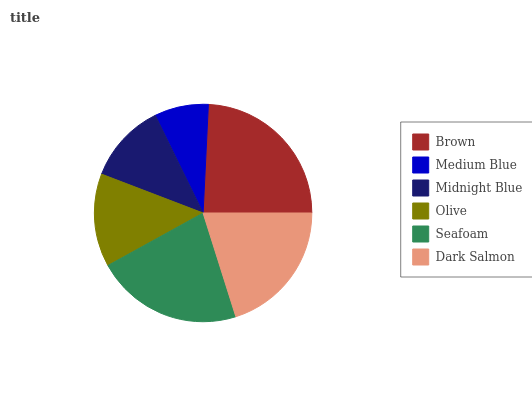Is Medium Blue the minimum?
Answer yes or no. Yes. Is Brown the maximum?
Answer yes or no. Yes. Is Midnight Blue the minimum?
Answer yes or no. No. Is Midnight Blue the maximum?
Answer yes or no. No. Is Midnight Blue greater than Medium Blue?
Answer yes or no. Yes. Is Medium Blue less than Midnight Blue?
Answer yes or no. Yes. Is Medium Blue greater than Midnight Blue?
Answer yes or no. No. Is Midnight Blue less than Medium Blue?
Answer yes or no. No. Is Dark Salmon the high median?
Answer yes or no. Yes. Is Olive the low median?
Answer yes or no. Yes. Is Brown the high median?
Answer yes or no. No. Is Dark Salmon the low median?
Answer yes or no. No. 